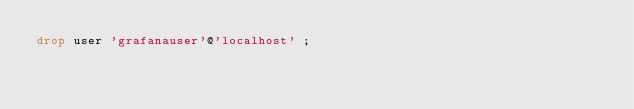<code> <loc_0><loc_0><loc_500><loc_500><_SQL_>drop user 'grafanauser'@'localhost' ;
</code> 